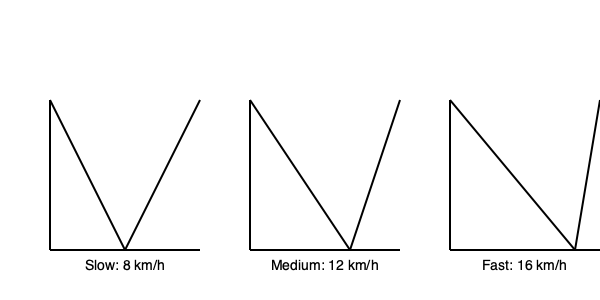As a triathlete, you're analyzing running biomechanics using stick figure diagrams. The image shows runners at three different speeds: 8 km/h, 12 km/h, and 16 km/h. Based on the diagrams, which factor contributes more to the increase in running speed: stride length or stride frequency? To analyze the contribution of stride length and stride frequency to running speed, let's examine the stick figure diagrams step-by-step:

1. Observe the overall pattern:
   - As speed increases from left to right, the stick figures show longer strides.
   - The angle between the legs also increases with speed.

2. Analyze stride length:
   - Slow runner (8 km/h): Shortest stride length
   - Medium runner (12 km/h): Moderate stride length
   - Fast runner (16 km/h): Longest stride length
   
   The increase in stride length is visually significant across all three speeds.

3. Infer stride frequency:
   - Stride frequency is not directly shown but can be inferred from the leg positions.
   - As speed increases, the angle between the legs widens, suggesting a slight increase in stride frequency.
   - However, the change in leg angle is less pronounced than the change in stride length.

4. Compare the relative changes:
   - Stride length shows a more substantial increase across the three speeds.
   - Stride frequency appears to increase, but to a lesser extent than stride length.

5. Consider the relationship between speed, stride length, and stride frequency:
   Speed = Stride Length × Stride Frequency

   Based on the visual representation, the increase in stride length appears to be the dominant factor in achieving higher speeds.

6. Biomechanical context:
   - In general, runners tend to increase both stride length and frequency as they speed up.
   - However, there are physiological limits to how much one can increase stride frequency, while stride length can be more readily extended with proper technique and strength.

Given the visual evidence and biomechanical principles, the diagrams suggest that stride length contributes more significantly to the increase in running speed compared to stride frequency.
Answer: Stride length 